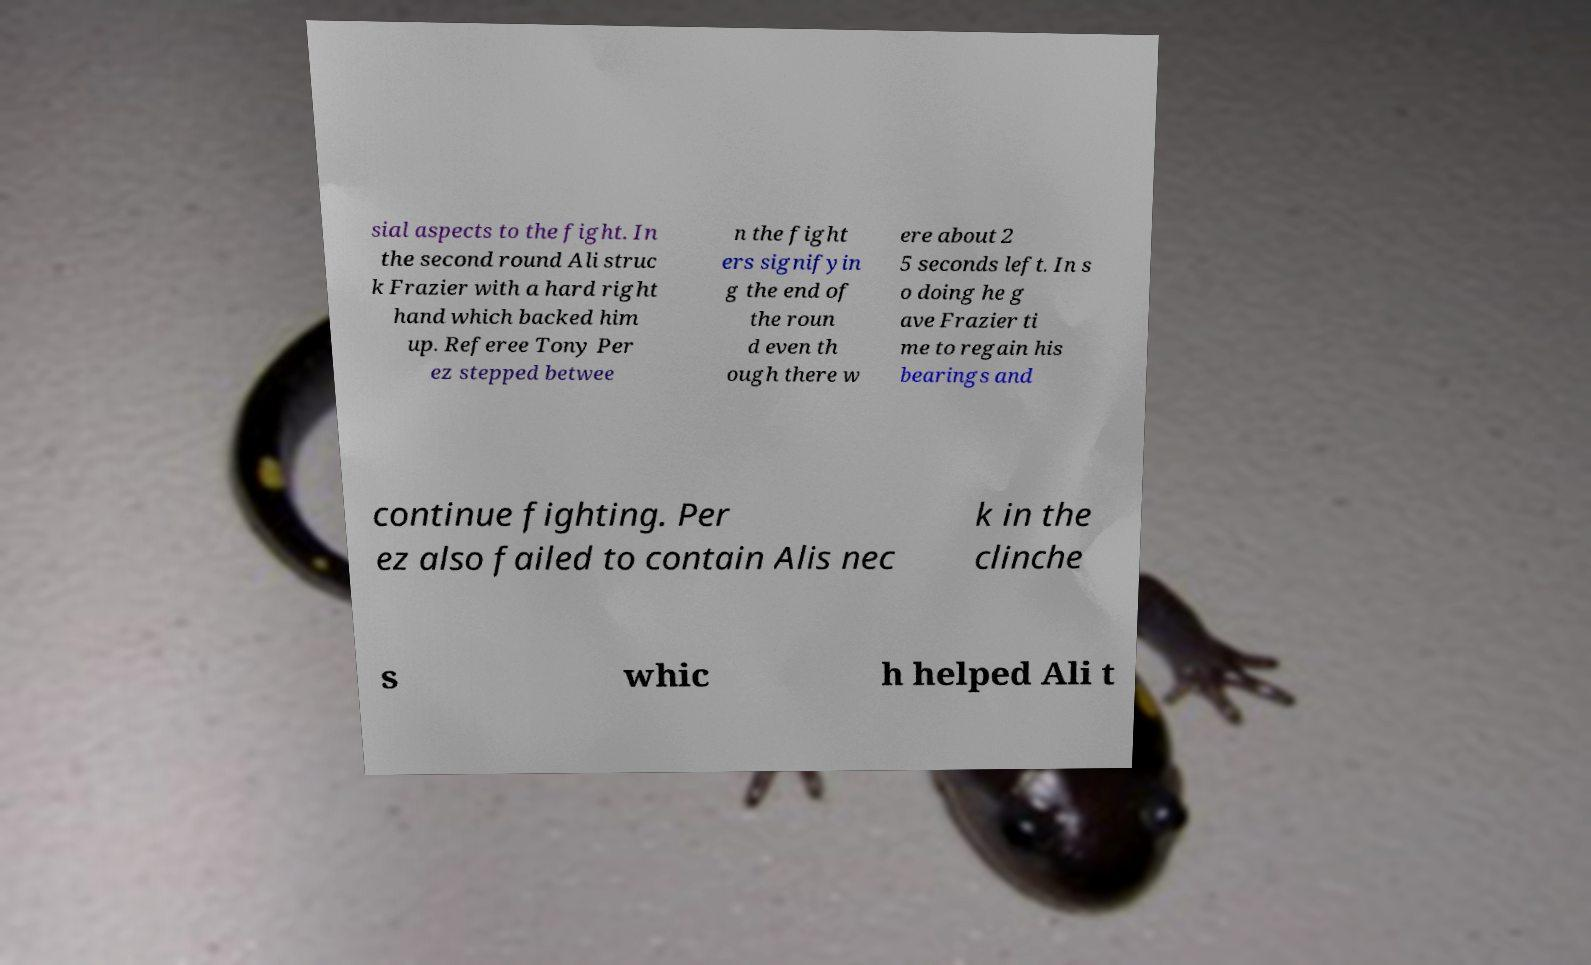What messages or text are displayed in this image? I need them in a readable, typed format. sial aspects to the fight. In the second round Ali struc k Frazier with a hard right hand which backed him up. Referee Tony Per ez stepped betwee n the fight ers signifyin g the end of the roun d even th ough there w ere about 2 5 seconds left. In s o doing he g ave Frazier ti me to regain his bearings and continue fighting. Per ez also failed to contain Alis nec k in the clinche s whic h helped Ali t 